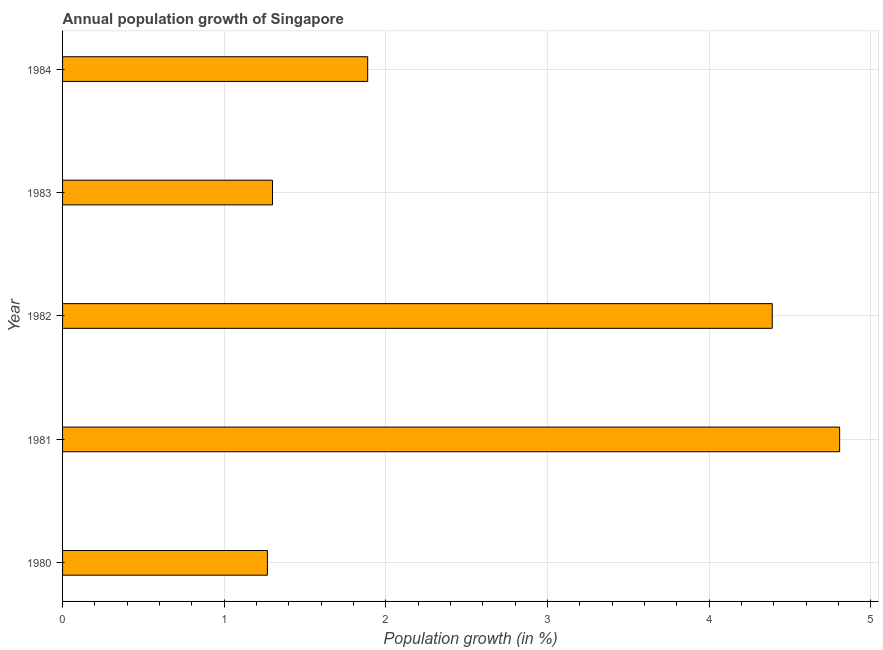Does the graph contain grids?
Offer a terse response. Yes. What is the title of the graph?
Your answer should be very brief. Annual population growth of Singapore. What is the label or title of the X-axis?
Your response must be concise. Population growth (in %). What is the label or title of the Y-axis?
Provide a short and direct response. Year. What is the population growth in 1980?
Give a very brief answer. 1.27. Across all years, what is the maximum population growth?
Provide a succinct answer. 4.81. Across all years, what is the minimum population growth?
Offer a terse response. 1.27. In which year was the population growth maximum?
Keep it short and to the point. 1981. What is the sum of the population growth?
Provide a short and direct response. 13.65. What is the difference between the population growth in 1982 and 1983?
Provide a short and direct response. 3.09. What is the average population growth per year?
Make the answer very short. 2.73. What is the median population growth?
Your response must be concise. 1.89. What is the ratio of the population growth in 1981 to that in 1984?
Provide a succinct answer. 2.55. What is the difference between the highest and the second highest population growth?
Your answer should be very brief. 0.42. What is the difference between the highest and the lowest population growth?
Your answer should be compact. 3.54. In how many years, is the population growth greater than the average population growth taken over all years?
Make the answer very short. 2. How many bars are there?
Offer a very short reply. 5. How many years are there in the graph?
Make the answer very short. 5. What is the Population growth (in %) in 1980?
Your response must be concise. 1.27. What is the Population growth (in %) in 1981?
Offer a very short reply. 4.81. What is the Population growth (in %) of 1982?
Make the answer very short. 4.39. What is the Population growth (in %) in 1983?
Your answer should be compact. 1.3. What is the Population growth (in %) of 1984?
Your response must be concise. 1.89. What is the difference between the Population growth (in %) in 1980 and 1981?
Ensure brevity in your answer.  -3.54. What is the difference between the Population growth (in %) in 1980 and 1982?
Ensure brevity in your answer.  -3.12. What is the difference between the Population growth (in %) in 1980 and 1983?
Make the answer very short. -0.03. What is the difference between the Population growth (in %) in 1980 and 1984?
Ensure brevity in your answer.  -0.62. What is the difference between the Population growth (in %) in 1981 and 1982?
Your answer should be compact. 0.42. What is the difference between the Population growth (in %) in 1981 and 1983?
Your answer should be very brief. 3.51. What is the difference between the Population growth (in %) in 1981 and 1984?
Provide a succinct answer. 2.92. What is the difference between the Population growth (in %) in 1982 and 1983?
Offer a very short reply. 3.09. What is the difference between the Population growth (in %) in 1982 and 1984?
Provide a succinct answer. 2.5. What is the difference between the Population growth (in %) in 1983 and 1984?
Keep it short and to the point. -0.59. What is the ratio of the Population growth (in %) in 1980 to that in 1981?
Your response must be concise. 0.26. What is the ratio of the Population growth (in %) in 1980 to that in 1982?
Your answer should be compact. 0.29. What is the ratio of the Population growth (in %) in 1980 to that in 1983?
Offer a terse response. 0.98. What is the ratio of the Population growth (in %) in 1980 to that in 1984?
Your answer should be very brief. 0.67. What is the ratio of the Population growth (in %) in 1981 to that in 1982?
Offer a very short reply. 1.09. What is the ratio of the Population growth (in %) in 1981 to that in 1983?
Give a very brief answer. 3.7. What is the ratio of the Population growth (in %) in 1981 to that in 1984?
Your response must be concise. 2.55. What is the ratio of the Population growth (in %) in 1982 to that in 1983?
Ensure brevity in your answer.  3.38. What is the ratio of the Population growth (in %) in 1982 to that in 1984?
Your answer should be very brief. 2.33. What is the ratio of the Population growth (in %) in 1983 to that in 1984?
Your answer should be compact. 0.69. 